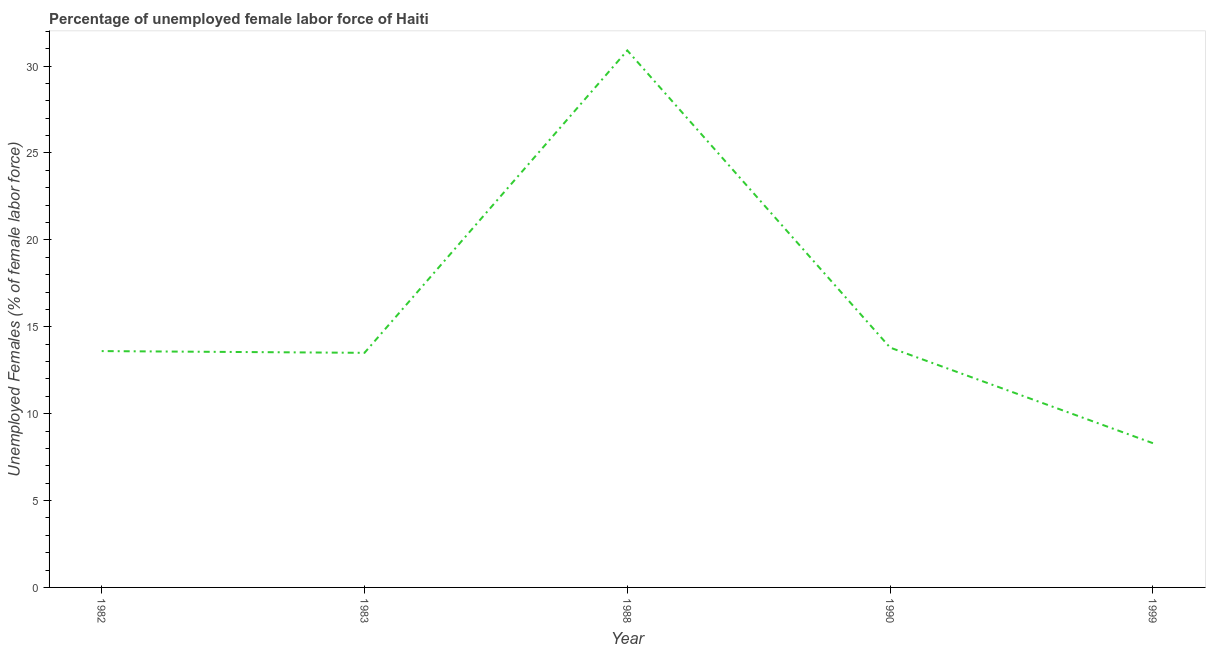What is the total unemployed female labour force in 1990?
Ensure brevity in your answer.  13.8. Across all years, what is the maximum total unemployed female labour force?
Keep it short and to the point. 30.9. Across all years, what is the minimum total unemployed female labour force?
Keep it short and to the point. 8.3. In which year was the total unemployed female labour force maximum?
Your answer should be compact. 1988. What is the sum of the total unemployed female labour force?
Your response must be concise. 80.1. What is the difference between the total unemployed female labour force in 1982 and 1988?
Your response must be concise. -17.3. What is the average total unemployed female labour force per year?
Keep it short and to the point. 16.02. What is the median total unemployed female labour force?
Provide a succinct answer. 13.6. What is the ratio of the total unemployed female labour force in 1982 to that in 1999?
Provide a short and direct response. 1.64. Is the total unemployed female labour force in 1988 less than that in 1999?
Your answer should be very brief. No. Is the difference between the total unemployed female labour force in 1988 and 1990 greater than the difference between any two years?
Make the answer very short. No. What is the difference between the highest and the second highest total unemployed female labour force?
Ensure brevity in your answer.  17.1. What is the difference between the highest and the lowest total unemployed female labour force?
Give a very brief answer. 22.6. What is the title of the graph?
Offer a terse response. Percentage of unemployed female labor force of Haiti. What is the label or title of the Y-axis?
Keep it short and to the point. Unemployed Females (% of female labor force). What is the Unemployed Females (% of female labor force) in 1982?
Give a very brief answer. 13.6. What is the Unemployed Females (% of female labor force) of 1983?
Provide a succinct answer. 13.5. What is the Unemployed Females (% of female labor force) in 1988?
Your response must be concise. 30.9. What is the Unemployed Females (% of female labor force) in 1990?
Provide a short and direct response. 13.8. What is the Unemployed Females (% of female labor force) in 1999?
Keep it short and to the point. 8.3. What is the difference between the Unemployed Females (% of female labor force) in 1982 and 1983?
Give a very brief answer. 0.1. What is the difference between the Unemployed Females (% of female labor force) in 1982 and 1988?
Your answer should be very brief. -17.3. What is the difference between the Unemployed Females (% of female labor force) in 1982 and 1990?
Offer a terse response. -0.2. What is the difference between the Unemployed Females (% of female labor force) in 1983 and 1988?
Provide a short and direct response. -17.4. What is the difference between the Unemployed Females (% of female labor force) in 1983 and 1990?
Give a very brief answer. -0.3. What is the difference between the Unemployed Females (% of female labor force) in 1983 and 1999?
Provide a succinct answer. 5.2. What is the difference between the Unemployed Females (% of female labor force) in 1988 and 1999?
Your answer should be very brief. 22.6. What is the difference between the Unemployed Females (% of female labor force) in 1990 and 1999?
Ensure brevity in your answer.  5.5. What is the ratio of the Unemployed Females (% of female labor force) in 1982 to that in 1983?
Your response must be concise. 1.01. What is the ratio of the Unemployed Females (% of female labor force) in 1982 to that in 1988?
Your answer should be very brief. 0.44. What is the ratio of the Unemployed Females (% of female labor force) in 1982 to that in 1999?
Your answer should be compact. 1.64. What is the ratio of the Unemployed Females (% of female labor force) in 1983 to that in 1988?
Offer a terse response. 0.44. What is the ratio of the Unemployed Females (% of female labor force) in 1983 to that in 1999?
Provide a succinct answer. 1.63. What is the ratio of the Unemployed Females (% of female labor force) in 1988 to that in 1990?
Provide a succinct answer. 2.24. What is the ratio of the Unemployed Females (% of female labor force) in 1988 to that in 1999?
Your answer should be very brief. 3.72. What is the ratio of the Unemployed Females (% of female labor force) in 1990 to that in 1999?
Provide a short and direct response. 1.66. 